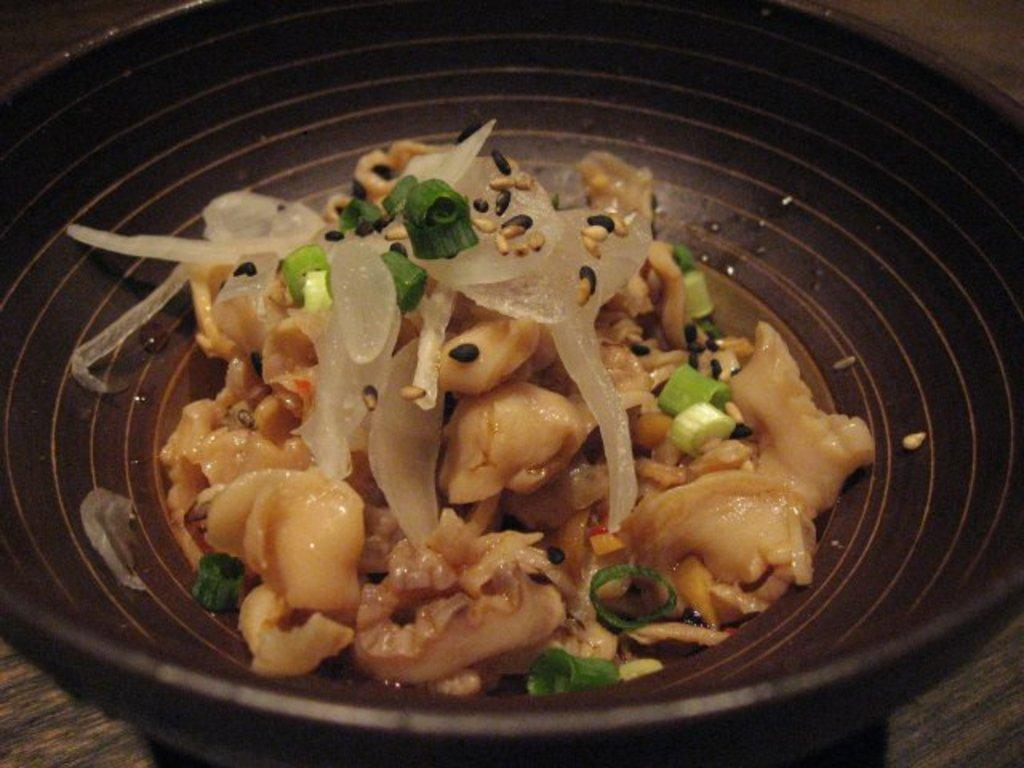What is the main subject of the image? There is a food item in the image. How is the food item presented? The food item is on a plate. Where is the plate located? The plate is on a table. What type of cracker is the queen holding in the image? There is no queen or cracker present in the image; it only features a food item on a plate. 